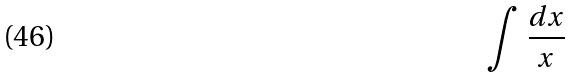Convert formula to latex. <formula><loc_0><loc_0><loc_500><loc_500>\int \frac { d x } { x }</formula> 